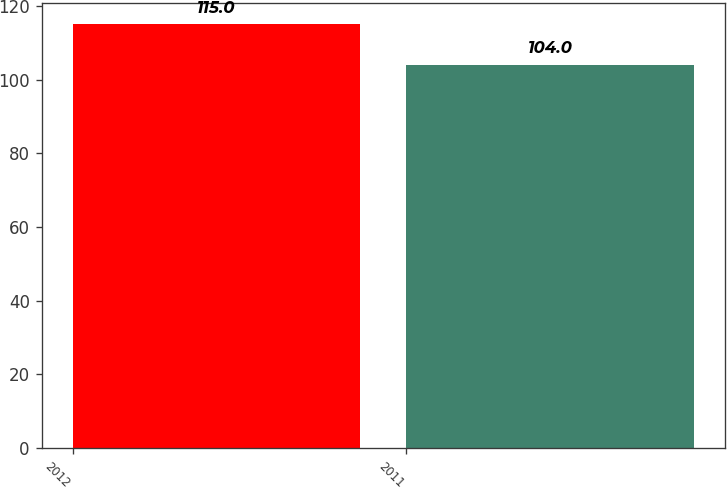<chart> <loc_0><loc_0><loc_500><loc_500><bar_chart><fcel>2012<fcel>2011<nl><fcel>115<fcel>104<nl></chart> 